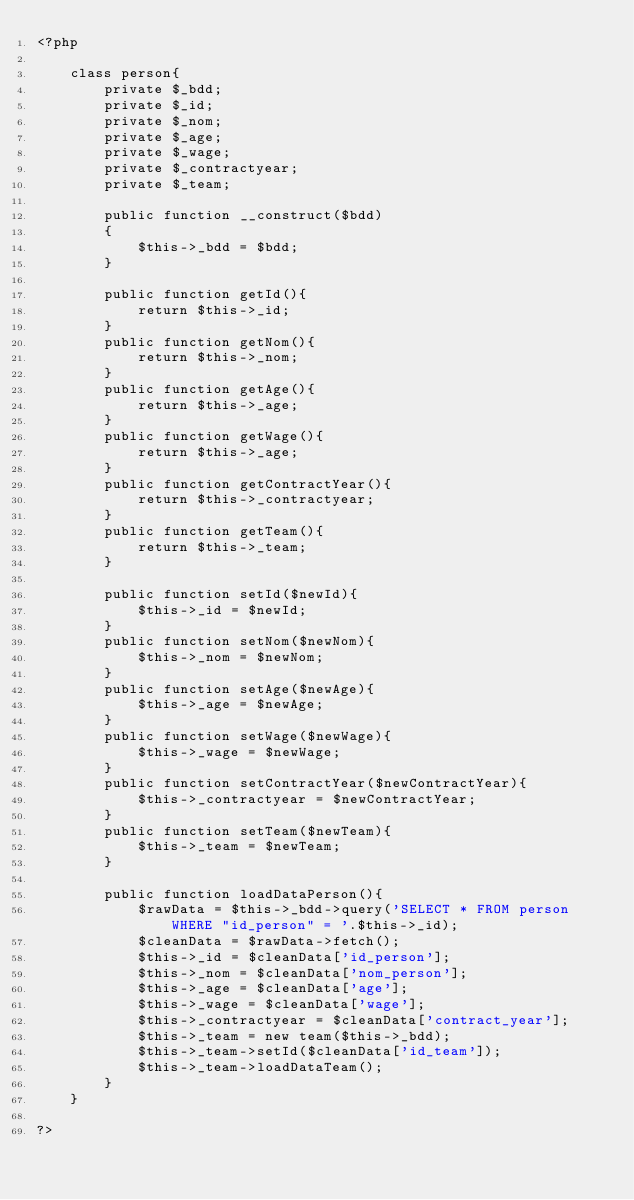<code> <loc_0><loc_0><loc_500><loc_500><_PHP_><?php

    class person{
        private $_bdd;
        private $_id;
        private $_nom;
        private $_age;
        private $_wage;
        private $_contractyear;
        private $_team;

        public function __construct($bdd)
        {  
            $this->_bdd = $bdd;
        }

        public function getId(){
            return $this->_id;
        }
        public function getNom(){
            return $this->_nom;
        }
        public function getAge(){
            return $this->_age;
        }
        public function getWage(){
            return $this->_age;
        }
        public function getContractYear(){
            return $this->_contractyear;
        }
        public function getTeam(){
            return $this->_team;
        }

        public function setId($newId){
            $this->_id = $newId;
        }
        public function setNom($newNom){
            $this->_nom = $newNom;
        }
        public function setAge($newAge){
            $this->_age = $newAge;
        }
        public function setWage($newWage){
            $this->_wage = $newWage;
        }
        public function setContractYear($newContractYear){
            $this->_contractyear = $newContractYear;
        }
        public function setTeam($newTeam){
            $this->_team = $newTeam;
        }

        public function loadDataPerson(){
            $rawData = $this->_bdd->query('SELECT * FROM person WHERE "id_person" = '.$this->_id);
            $cleanData = $rawData->fetch();
            $this->_id = $cleanData['id_person'];
            $this->_nom = $cleanData['nom_person'];
            $this->_age = $cleanData['age'];
            $this->_wage = $cleanData['wage'];
            $this->_contractyear = $cleanData['contract_year'];
            $this->_team = new team($this->_bdd);
            $this->_team->setId($cleanData['id_team']);
            $this->_team->loadDataTeam(); 
        }
    }

?></code> 